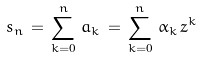Convert formula to latex. <formula><loc_0><loc_0><loc_500><loc_500>s _ { n } \, = \, \sum _ { k = 0 } ^ { n } \, a _ { k } \, = \, \sum _ { k = 0 } ^ { n } \, \alpha _ { k } \, z ^ { k }</formula> 